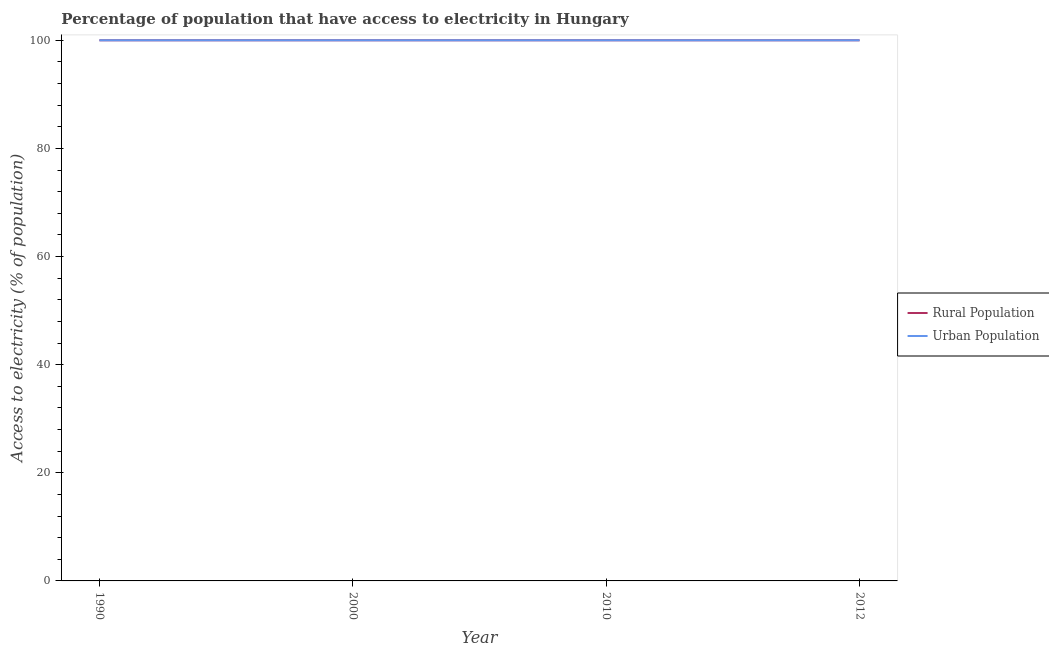How many different coloured lines are there?
Offer a terse response. 2. Does the line corresponding to percentage of rural population having access to electricity intersect with the line corresponding to percentage of urban population having access to electricity?
Your answer should be very brief. Yes. What is the percentage of urban population having access to electricity in 2010?
Offer a very short reply. 100. Across all years, what is the maximum percentage of urban population having access to electricity?
Provide a succinct answer. 100. Across all years, what is the minimum percentage of urban population having access to electricity?
Your answer should be compact. 100. What is the total percentage of urban population having access to electricity in the graph?
Your answer should be compact. 400. What is the difference between the percentage of urban population having access to electricity in 1990 and that in 2000?
Make the answer very short. 0. What is the difference between the percentage of rural population having access to electricity in 1990 and the percentage of urban population having access to electricity in 2012?
Your answer should be very brief. 0. What is the average percentage of rural population having access to electricity per year?
Offer a very short reply. 100. What is the ratio of the percentage of urban population having access to electricity in 1990 to that in 2012?
Make the answer very short. 1. In how many years, is the percentage of rural population having access to electricity greater than the average percentage of rural population having access to electricity taken over all years?
Offer a very short reply. 0. Is the sum of the percentage of urban population having access to electricity in 2000 and 2012 greater than the maximum percentage of rural population having access to electricity across all years?
Your response must be concise. Yes. Is the percentage of urban population having access to electricity strictly greater than the percentage of rural population having access to electricity over the years?
Your answer should be compact. No. How many lines are there?
Ensure brevity in your answer.  2. Does the graph contain any zero values?
Offer a very short reply. No. Does the graph contain grids?
Give a very brief answer. No. Where does the legend appear in the graph?
Offer a very short reply. Center right. How are the legend labels stacked?
Make the answer very short. Vertical. What is the title of the graph?
Provide a short and direct response. Percentage of population that have access to electricity in Hungary. What is the label or title of the X-axis?
Make the answer very short. Year. What is the label or title of the Y-axis?
Give a very brief answer. Access to electricity (% of population). What is the Access to electricity (% of population) in Urban Population in 1990?
Provide a short and direct response. 100. What is the Access to electricity (% of population) of Rural Population in 2000?
Your response must be concise. 100. What is the Access to electricity (% of population) of Rural Population in 2010?
Keep it short and to the point. 100. What is the Access to electricity (% of population) in Urban Population in 2010?
Provide a short and direct response. 100. What is the Access to electricity (% of population) in Urban Population in 2012?
Offer a terse response. 100. Across all years, what is the maximum Access to electricity (% of population) in Rural Population?
Your answer should be very brief. 100. Across all years, what is the maximum Access to electricity (% of population) of Urban Population?
Your response must be concise. 100. What is the total Access to electricity (% of population) of Rural Population in the graph?
Ensure brevity in your answer.  400. What is the difference between the Access to electricity (% of population) in Urban Population in 1990 and that in 2000?
Provide a short and direct response. 0. What is the difference between the Access to electricity (% of population) of Rural Population in 1990 and that in 2010?
Your answer should be very brief. 0. What is the difference between the Access to electricity (% of population) of Urban Population in 1990 and that in 2010?
Provide a succinct answer. 0. What is the difference between the Access to electricity (% of population) in Urban Population in 2000 and that in 2010?
Offer a very short reply. 0. What is the difference between the Access to electricity (% of population) in Rural Population in 2000 and that in 2012?
Offer a very short reply. 0. What is the difference between the Access to electricity (% of population) in Urban Population in 2000 and that in 2012?
Give a very brief answer. 0. What is the difference between the Access to electricity (% of population) of Rural Population in 2010 and that in 2012?
Offer a terse response. 0. What is the difference between the Access to electricity (% of population) in Urban Population in 2010 and that in 2012?
Provide a short and direct response. 0. What is the difference between the Access to electricity (% of population) in Rural Population in 1990 and the Access to electricity (% of population) in Urban Population in 2000?
Give a very brief answer. 0. What is the difference between the Access to electricity (% of population) of Rural Population in 1990 and the Access to electricity (% of population) of Urban Population in 2010?
Your response must be concise. 0. What is the difference between the Access to electricity (% of population) in Rural Population in 2010 and the Access to electricity (% of population) in Urban Population in 2012?
Provide a short and direct response. 0. What is the average Access to electricity (% of population) in Rural Population per year?
Make the answer very short. 100. What is the average Access to electricity (% of population) of Urban Population per year?
Provide a succinct answer. 100. In the year 1990, what is the difference between the Access to electricity (% of population) in Rural Population and Access to electricity (% of population) in Urban Population?
Ensure brevity in your answer.  0. In the year 2000, what is the difference between the Access to electricity (% of population) of Rural Population and Access to electricity (% of population) of Urban Population?
Your answer should be very brief. 0. In the year 2010, what is the difference between the Access to electricity (% of population) in Rural Population and Access to electricity (% of population) in Urban Population?
Your answer should be compact. 0. What is the ratio of the Access to electricity (% of population) in Rural Population in 1990 to that in 2000?
Provide a succinct answer. 1. What is the ratio of the Access to electricity (% of population) in Rural Population in 1990 to that in 2010?
Provide a short and direct response. 1. What is the ratio of the Access to electricity (% of population) in Rural Population in 1990 to that in 2012?
Your response must be concise. 1. What is the ratio of the Access to electricity (% of population) of Urban Population in 1990 to that in 2012?
Your answer should be compact. 1. What is the ratio of the Access to electricity (% of population) in Rural Population in 2000 to that in 2010?
Offer a very short reply. 1. What is the ratio of the Access to electricity (% of population) of Urban Population in 2000 to that in 2010?
Provide a short and direct response. 1. What is the ratio of the Access to electricity (% of population) of Rural Population in 2000 to that in 2012?
Provide a succinct answer. 1. What is the difference between the highest and the second highest Access to electricity (% of population) of Rural Population?
Offer a terse response. 0. 